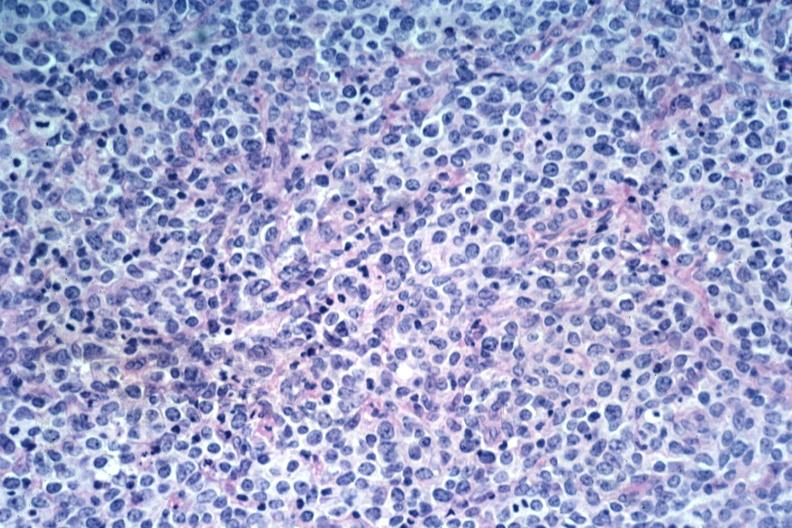what is present?
Answer the question using a single word or phrase. Lymph node 